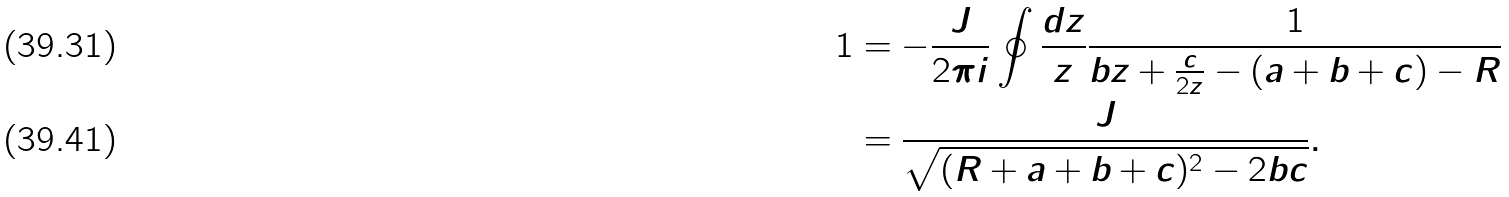<formula> <loc_0><loc_0><loc_500><loc_500>1 & = - \frac { J } { 2 \pi i } \oint \frac { d z } { z } \frac { 1 } { b z + \frac { c } { 2 z } - ( a + b + c ) - R } \\ & = \frac { J } { \sqrt { ( R + a + b + c ) ^ { 2 } - 2 b c } } .</formula> 